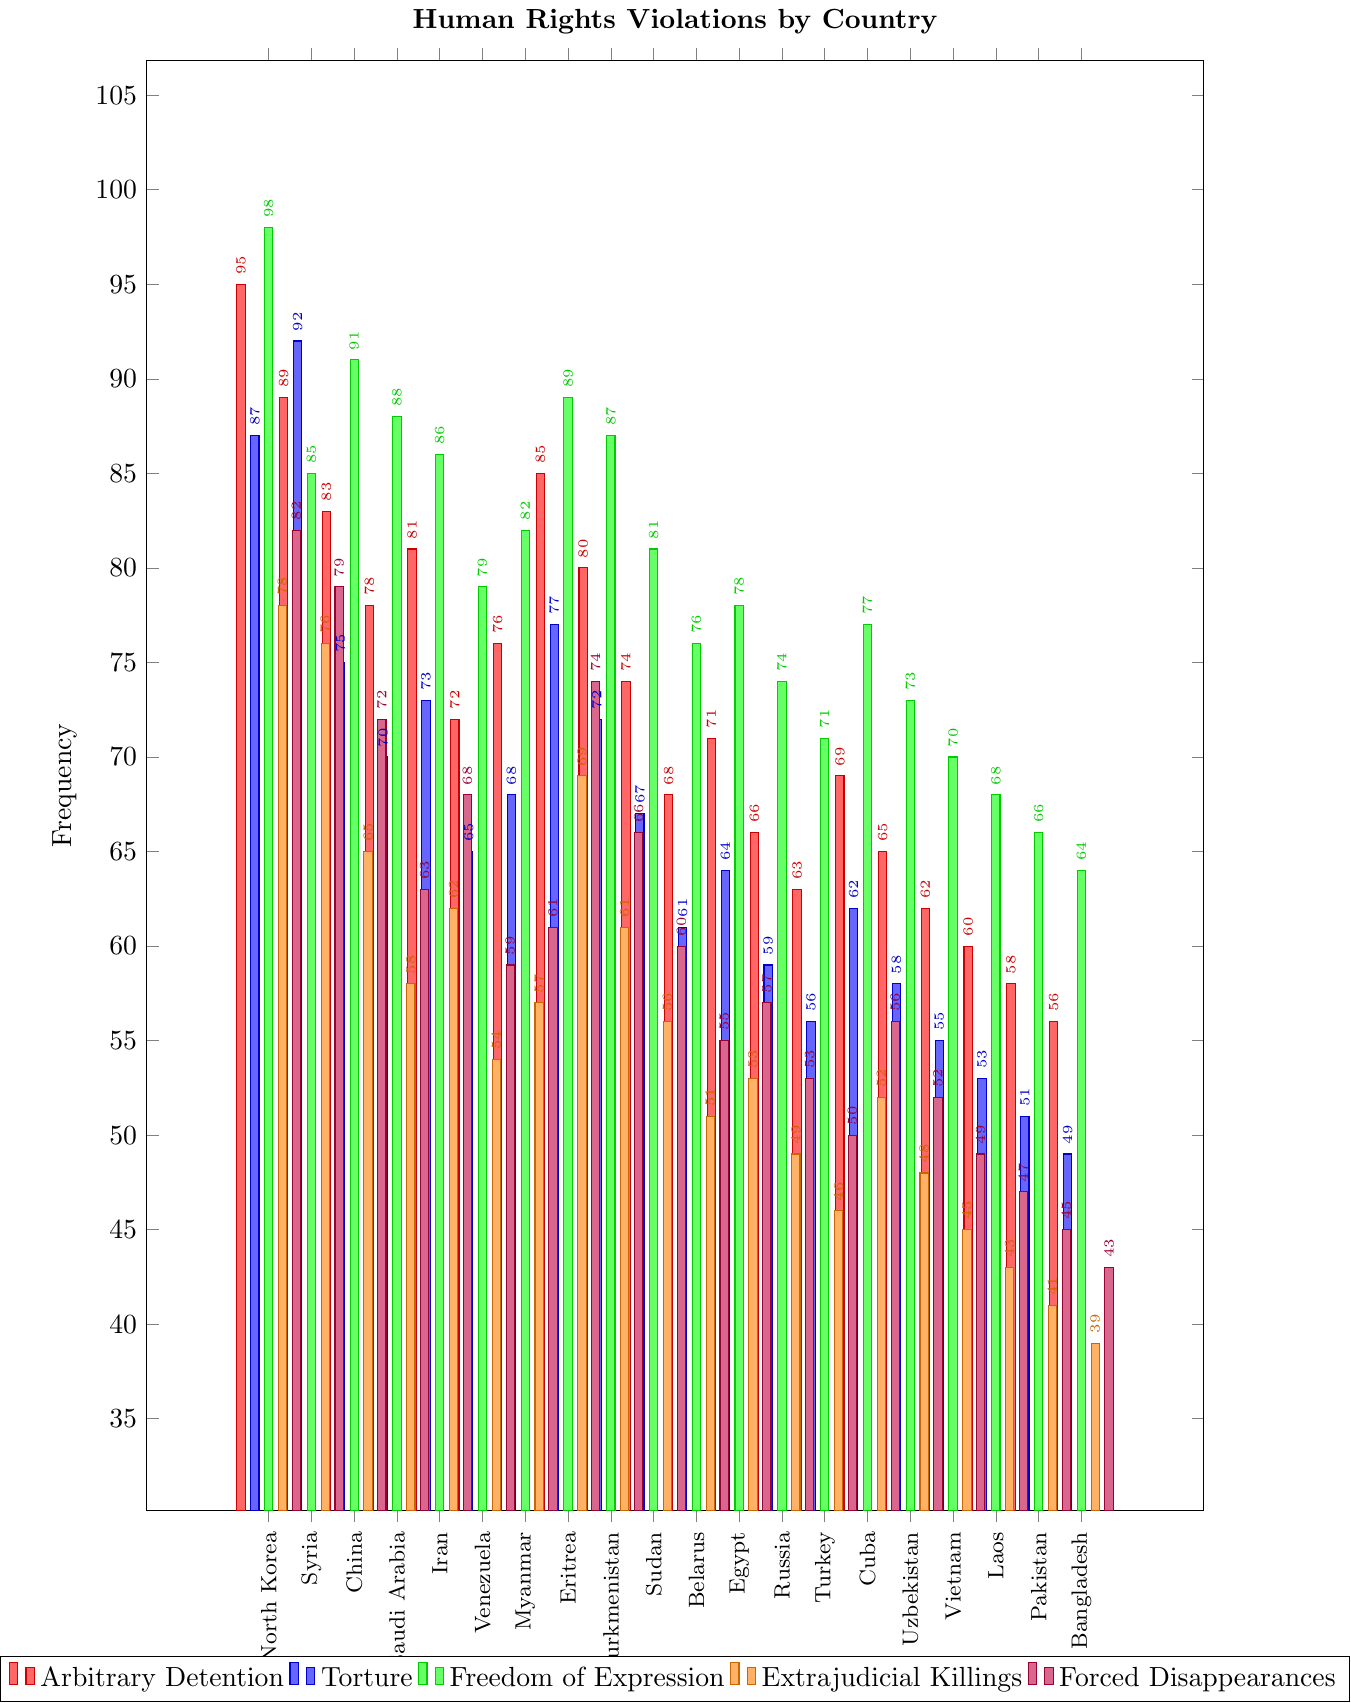What's the country with the highest frequency of human rights violations in the category of Torture? By examining the bar corresponding to Torture in each country, the highest is Syria with a frequency of 92.
Answer: Syria Which country has a lower frequency of Extrajudicial Killings, Iran or Venezuela? The bar for Extrajudicial Killings for Iran is at 62, and for Venezuela, it is at 54. Thus, Venezuela has a lower frequency.
Answer: Venezuela What is the difference in the frequency of Freedom of Expression violations between China and Myanmar? The Freedom of Expression frequency for China is 91, and for Myanmar, it is 82. The difference is 91 - 82.
Answer: 9 How many countries have a Freedom of Expression violations frequency of less than 75? By observing the Freedom of Expression bars for all countries, Belarus (76), Egypt (78), Russia (74), Turkey (71), Cuba (77), Uzbekistan (73), Vietnam (70), Laos (68), Pakistan (66), and Bangladesh (64) have frequencies less than 75.
Answer: 7 Which country shows the highest frequency in the category of Forced Disappearances? By examining the Forced Disappearances bar for each country, North Korea has the highest frequency at 82.
Answer: North Korea Is the frequency of Arbitrary Detention in Eritrea higher than in Sudan? The Arbitrary Detention frequency for Eritrea is 85, and for Sudan, it is 74. Yes, Eritrea is higher.
Answer: Yes What is the sum of Torture and Extrajudicial Killings frequencies for Turkey? For Turkey, Torture is 56, and Extrajudicial Killings is 46. The sum is 56 + 46.
Answer: 102 Are there any countries where the frequency of Arbitrary Detention is exactly equal to Forced Disappearances? By comparing the values, there are no countries where the frequency of Arbitrary Detention and Forced Disappearances match exactly.
Answer: No Which country displays a lower frequency of violations in the category of Arbitrary Detention, Belarus or Uzbekistan? The Arbitrary Detention frequency for Belarus is 68, and for Uzbekistan, it is 65. Uzbekistan is lower.
Answer: Uzbekistan 